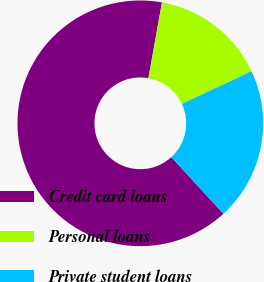Convert chart. <chart><loc_0><loc_0><loc_500><loc_500><pie_chart><fcel>Credit card loans<fcel>Personal loans<fcel>Private student loans<nl><fcel>64.64%<fcel>15.21%<fcel>20.15%<nl></chart> 